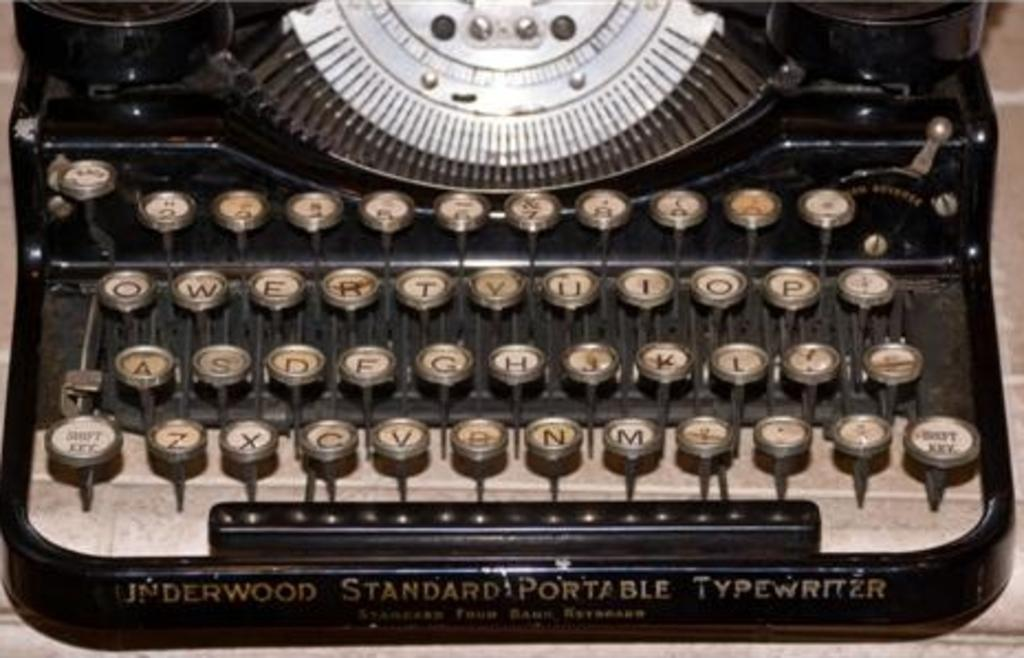<image>
Provide a brief description of the given image. The keyboard of a vintage Underwood Standard portable typewriter. 